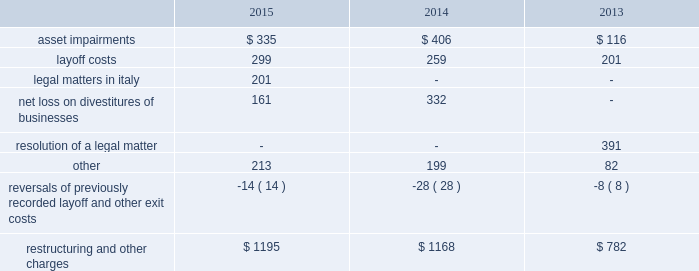Restructuring and other charges 2014restructuring and other charges for each year in the three-year period ended december 31 , 2015 were comprised of the following: .
Layoff costs were recorded based on approved detailed action plans submitted by the operating locations that specified positions to be eliminated , benefits to be paid under existing severance plans , union contracts or statutory requirements , and the expected timetable for completion of the plans .
2015 actions .
In 2015 , alcoa recorded restructuring and other charges of $ 1195 ( $ 836 after-tax and noncontrolling interest ) , which were comprised of the following components : $ 438 ( $ 281 after-tax and noncontrolling interest ) for exit costs related to decisions to permanently shut down and demolish three smelters and a power station ( see below ) ; $ 246 ( $ 118 after-tax and noncontrolling interest ) for the curtailment of two refineries and two smelters ( see below ) ; $ 201 ( pre- and after-tax ) related to legal matters in italy ; a $ 161 ( $ 151 after-tax and noncontrolling interest ) net loss related to the march 2015 divestiture of a rolling mill in russia ( see global rolled products in segment information below ) and post-closing adjustments associated with three december 2014 divestitures ; $ 143 ( $ 102 after-tax and noncontrolling interest ) for layoff costs , including the separation of approximately 2100 employees ( 425 in the transportation and construction solutions segment , 645 in the engineered products and solutions segment , 380 in the primary metals segment , 90 in the global rolled products segment , 85 in the alumina segment , and 475 in corporate ) ; $ 34 ( $ 14 after-tax and noncontrolling interest ) for asset impairments , virtually all of which was related to prior capitalized costs for an expansion project at a refinery in australia that is no longer being pursued ; an $ 18 ( $ 13 after- tax ) gain on the sale of land related to one of the rolling mills in australia that was permanently closed in december 2014 ( see 2014 actions below ) ; a net charge of $ 4 ( a net credit of $ 7 after-tax and noncontrolling interest ) for other miscellaneous items ; and $ 14 ( $ 11 after-tax and noncontrolling interest ) for the reversal of a number of small layoff reserves related to prior periods .
During 2015 , management initiated various alumina refining and aluminum smelting capacity curtailments and/or closures .
The curtailments were composed of the remaining capacity at all of the following : the s e3o lu eds smelter in brazil ( 74 kmt-per-year ) ; the suriname refinery ( 1330 kmt-per-year ) ; the point comfort , tx refinery ( 2010 kmt-per- year ) ; and the wenatchee , wa smelter ( 143 kmt-per-year ) .
All of the curtailments were completed in 2015 except for 1635 kmt-per-year at the point comfort refinery , which is expected to be completed by the end of june 2016 .
The permanent closures were composed of the capacity at the warrick , in smelter ( 269 kmt-per-year ) ( includes the closure of a related coal mine ) and the infrastructure of the massena east , ny smelter ( potlines were previously shut down in both 2013 and 2014 2014see 2013 actions and 2014 actions below ) , as the modernization of this smelter is no longer being pursued .
The shutdown of the warrick smelter is expected to be completed by the end of march 2016 .
The decisions on the above actions were part of a separate 12-month review in refining ( 2800 kmt-per-year ) and smelting ( 500 kmt-per-year ) capacity initiated by management in march 2015 for possible curtailment ( partial or full ) , permanent closure or divestiture .
While many factors contributed to each decision , in general , these actions were initiated to maintain competitiveness amid prevailing market conditions for both alumina and aluminum .
Demolition and remediation activities related to the warrick smelter and the massena east location will begin in 2016 and are expected to be completed by the end of 2020 .
Separate from the actions initiated under the reviews described above , in mid-2015 , management approved the permanent shutdown and demolition of the po e7os de caldas smelter ( capacity of 96 kmt-per-year ) in brazil and the .
What is the percentual growth observed in the percentage of asset impairment costs concerning the restructuring and other charges costs during 2013 and 2014? 
Rationale: it is the difference between the percentage of asset impairment costs concerning the restructuring and other charges costs in 2013 and 2014
Computations: ((406 / 1168) - (116 / 782))
Answer: 0.19927. 